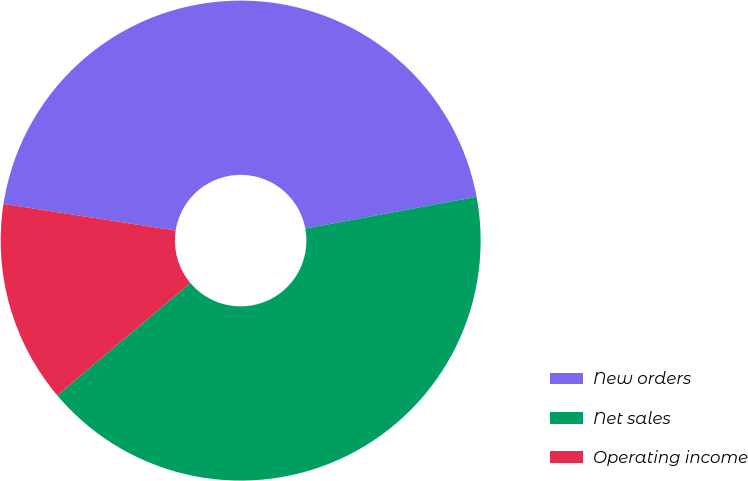Convert chart to OTSL. <chart><loc_0><loc_0><loc_500><loc_500><pie_chart><fcel>New orders<fcel>Net sales<fcel>Operating income<nl><fcel>44.63%<fcel>41.76%<fcel>13.6%<nl></chart> 